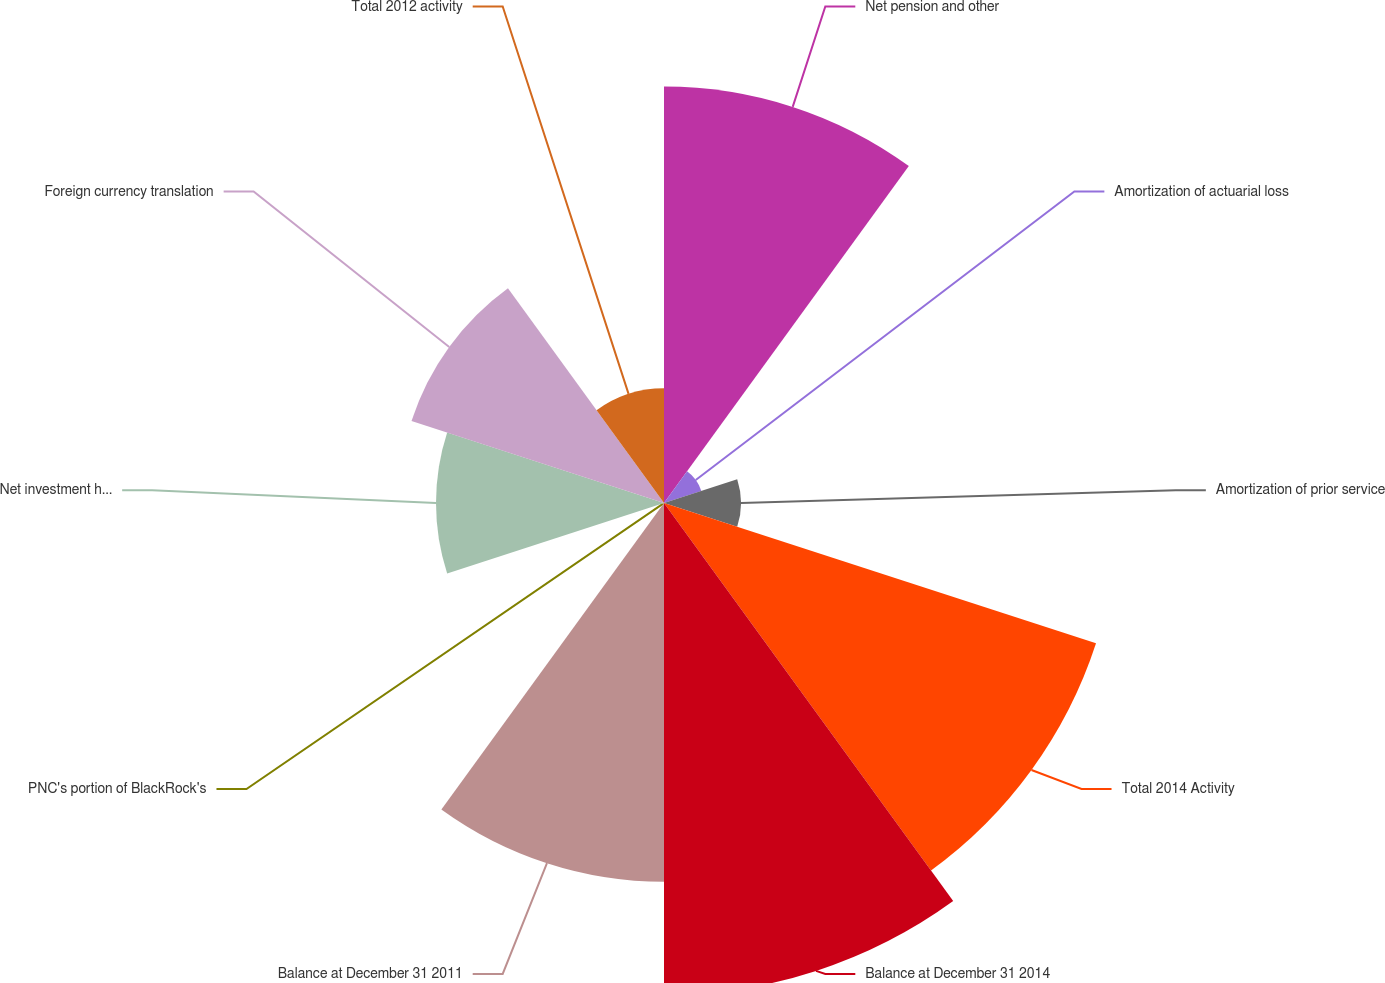Convert chart to OTSL. <chart><loc_0><loc_0><loc_500><loc_500><pie_chart><fcel>Net pension and other<fcel>Amortization of actuarial loss<fcel>Amortization of prior service<fcel>Total 2014 Activity<fcel>Balance at December 31 2014<fcel>Balance at December 31 2011<fcel>PNC's portion of BlackRock's<fcel>Net investment hedge<fcel>Foreign currency translation<fcel>Total 2012 activity<nl><fcel>16.88%<fcel>1.59%<fcel>3.12%<fcel>18.41%<fcel>19.94%<fcel>15.35%<fcel>0.06%<fcel>9.24%<fcel>10.76%<fcel>4.65%<nl></chart> 